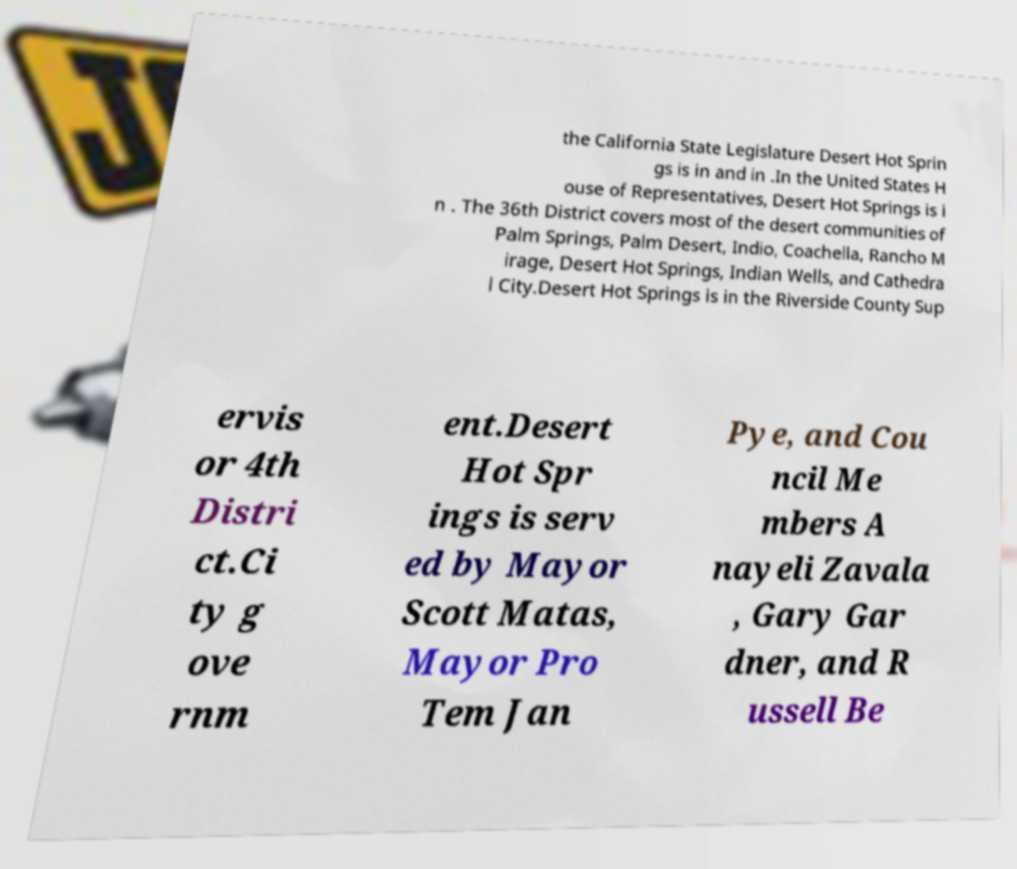Can you read and provide the text displayed in the image?This photo seems to have some interesting text. Can you extract and type it out for me? the California State Legislature Desert Hot Sprin gs is in and in .In the United States H ouse of Representatives, Desert Hot Springs is i n . The 36th District covers most of the desert communities of Palm Springs, Palm Desert, Indio, Coachella, Rancho M irage, Desert Hot Springs, Indian Wells, and Cathedra l City.Desert Hot Springs is in the Riverside County Sup ervis or 4th Distri ct.Ci ty g ove rnm ent.Desert Hot Spr ings is serv ed by Mayor Scott Matas, Mayor Pro Tem Jan Pye, and Cou ncil Me mbers A nayeli Zavala , Gary Gar dner, and R ussell Be 